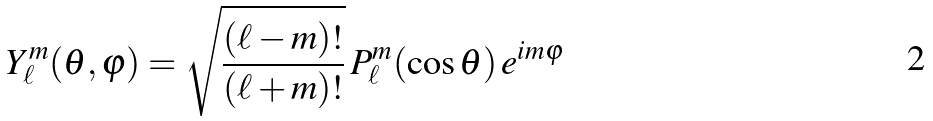<formula> <loc_0><loc_0><loc_500><loc_500>Y _ { \ell } ^ { m } ( \theta , \varphi ) = { \sqrt { \frac { ( \ell - m ) ! } { ( \ell + m ) ! } } } \, P _ { \ell } ^ { m } ( \cos { \theta } ) \, e ^ { i m \varphi }</formula> 